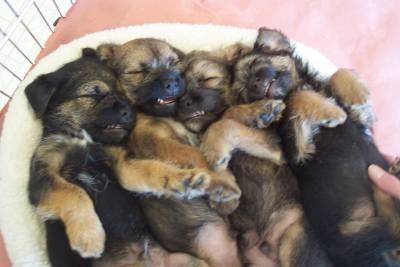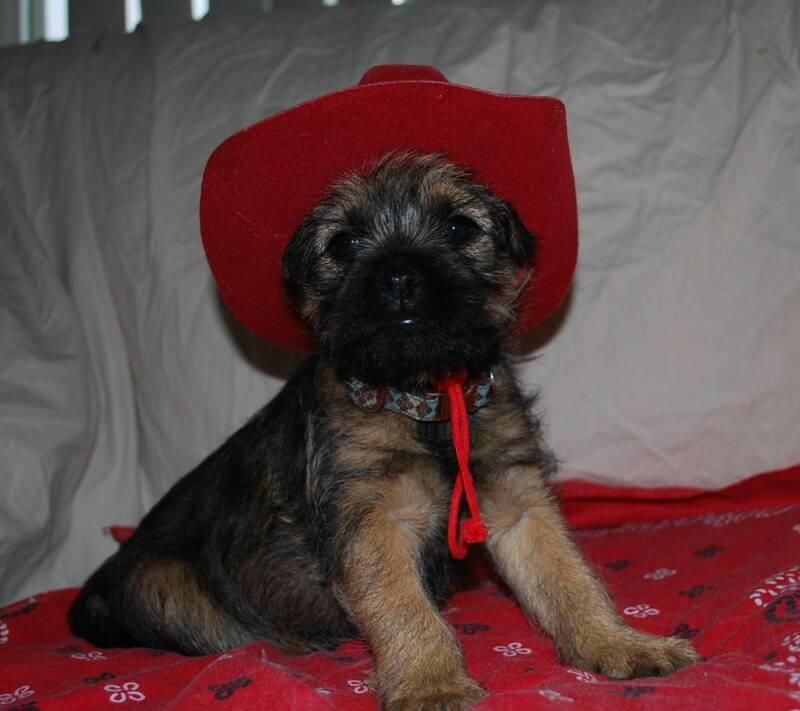The first image is the image on the left, the second image is the image on the right. Assess this claim about the two images: "Each image shows the face of one dog, but only the lefthand image features a dog with an open mouth.". Correct or not? Answer yes or no. No. The first image is the image on the left, the second image is the image on the right. Evaluate the accuracy of this statement regarding the images: "Each dog is outside in the grass.". Is it true? Answer yes or no. No. 